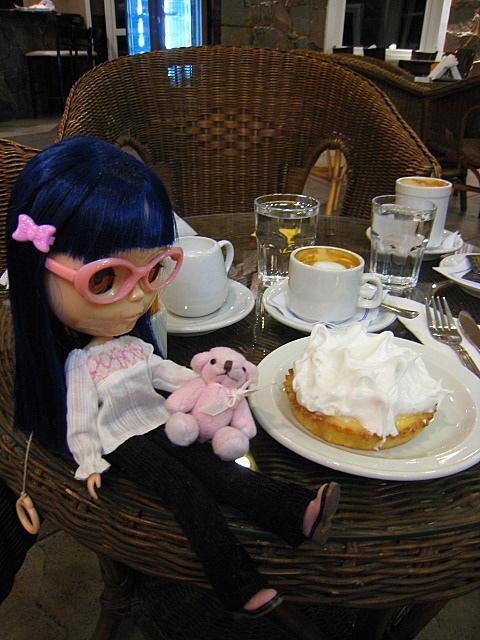How many cups can be seen?
Give a very brief answer. 4. 